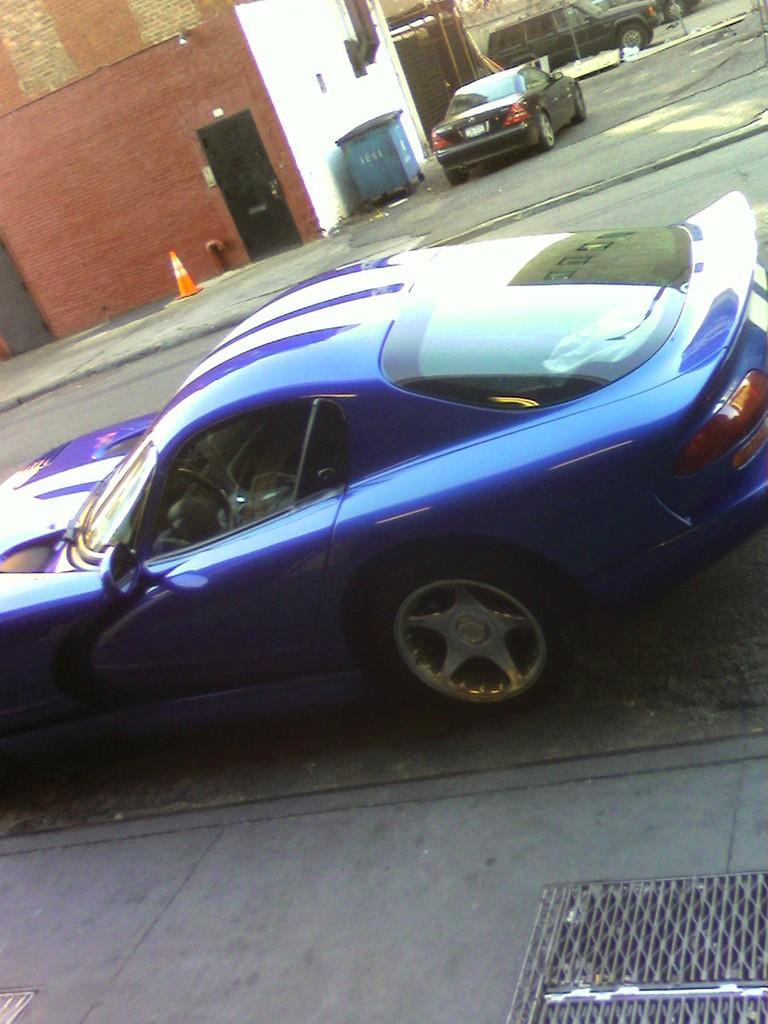Describe this image in one or two sentences. This picture is clicked outside. In the center there is a blue color car parked on the ground. In the background we can see some other cars seems to be running on the road and we can see the buildings and some other objects and the door of the building. 